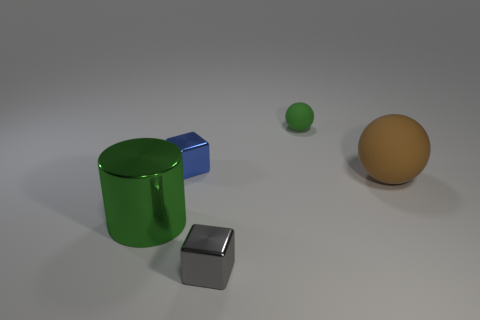There is a green rubber ball right of the blue metal object; what size is it? The green rubber ball appears to be relatively small compared to the surrounding objects, such as the blue metal object and the larger orange ball. 